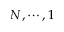<formula> <loc_0><loc_0><loc_500><loc_500>N , \cdots , 1</formula> 